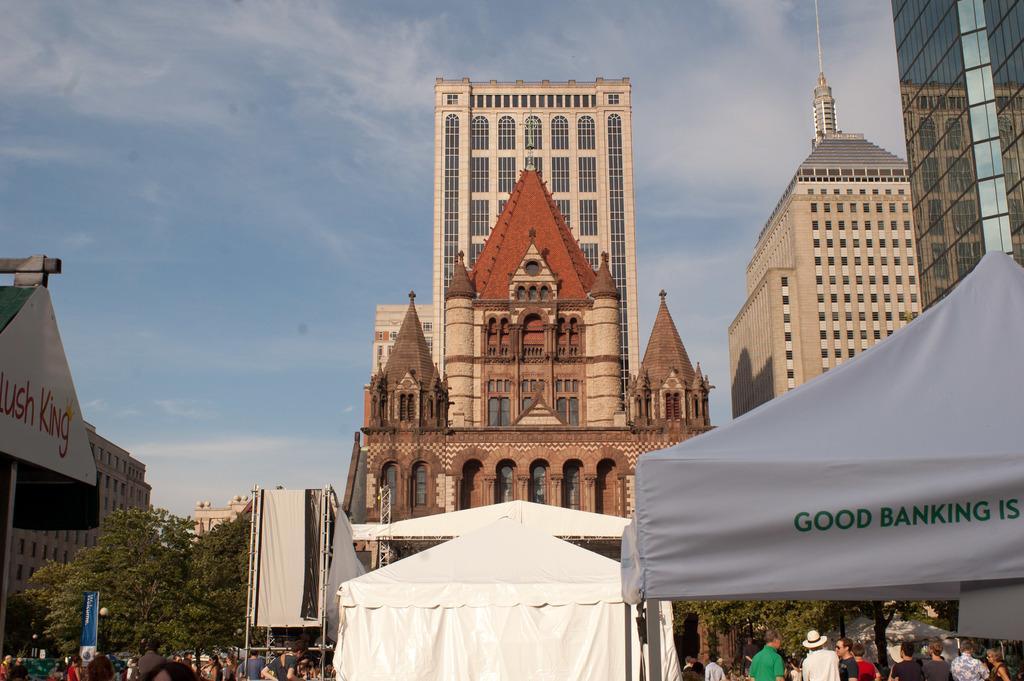In one or two sentences, can you explain what this image depicts? On the left side there are trees, in the middle there are people and tents. At the back side there are very big buildings, at the top it is the sky. 